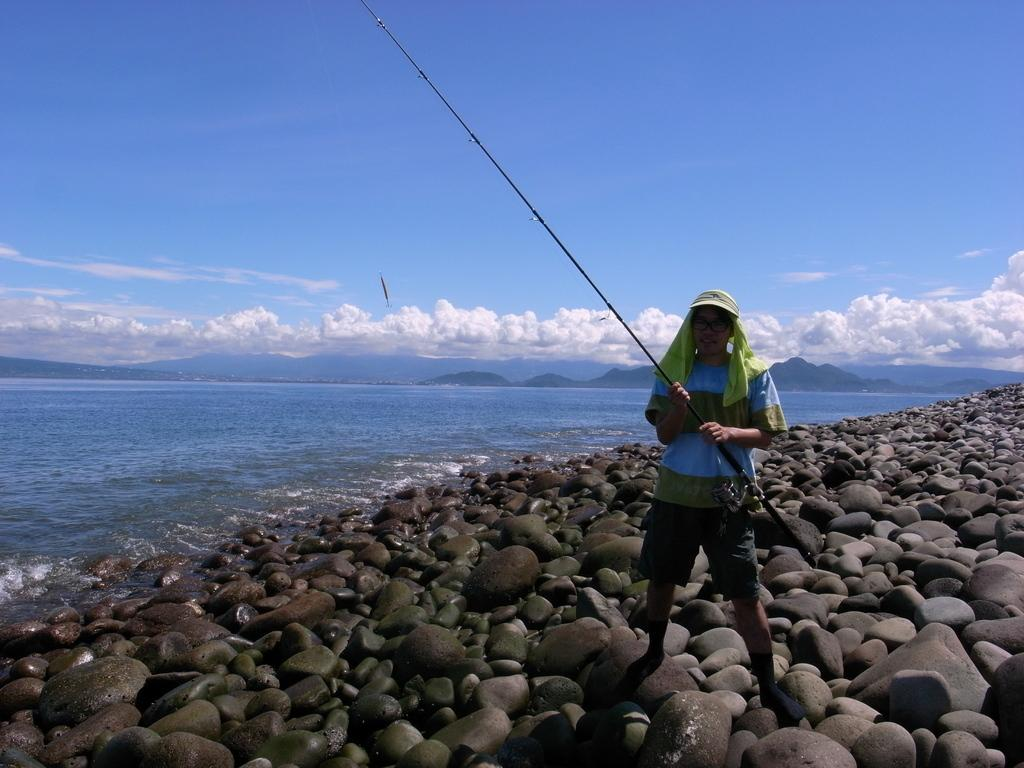Who is present in the image? There is a person in the image. What is the person doing in the image? The person is holding a fishing rod. What is the person standing on in the image? The person is standing on stones. What can be seen in the distance in the image? There is a large water body and mountains visible in the background. How would you describe the weather in the image? The sky is cloudy in the image. What type of shop can be seen in the image? There is no shop present in the image; it features a person holding a fishing rod and standing on stones near a large water body and mountains. How hot is the person in the image? The temperature of the person cannot be determined from the image, as it does not provide any information about the weather conditions or the person's body temperature. 